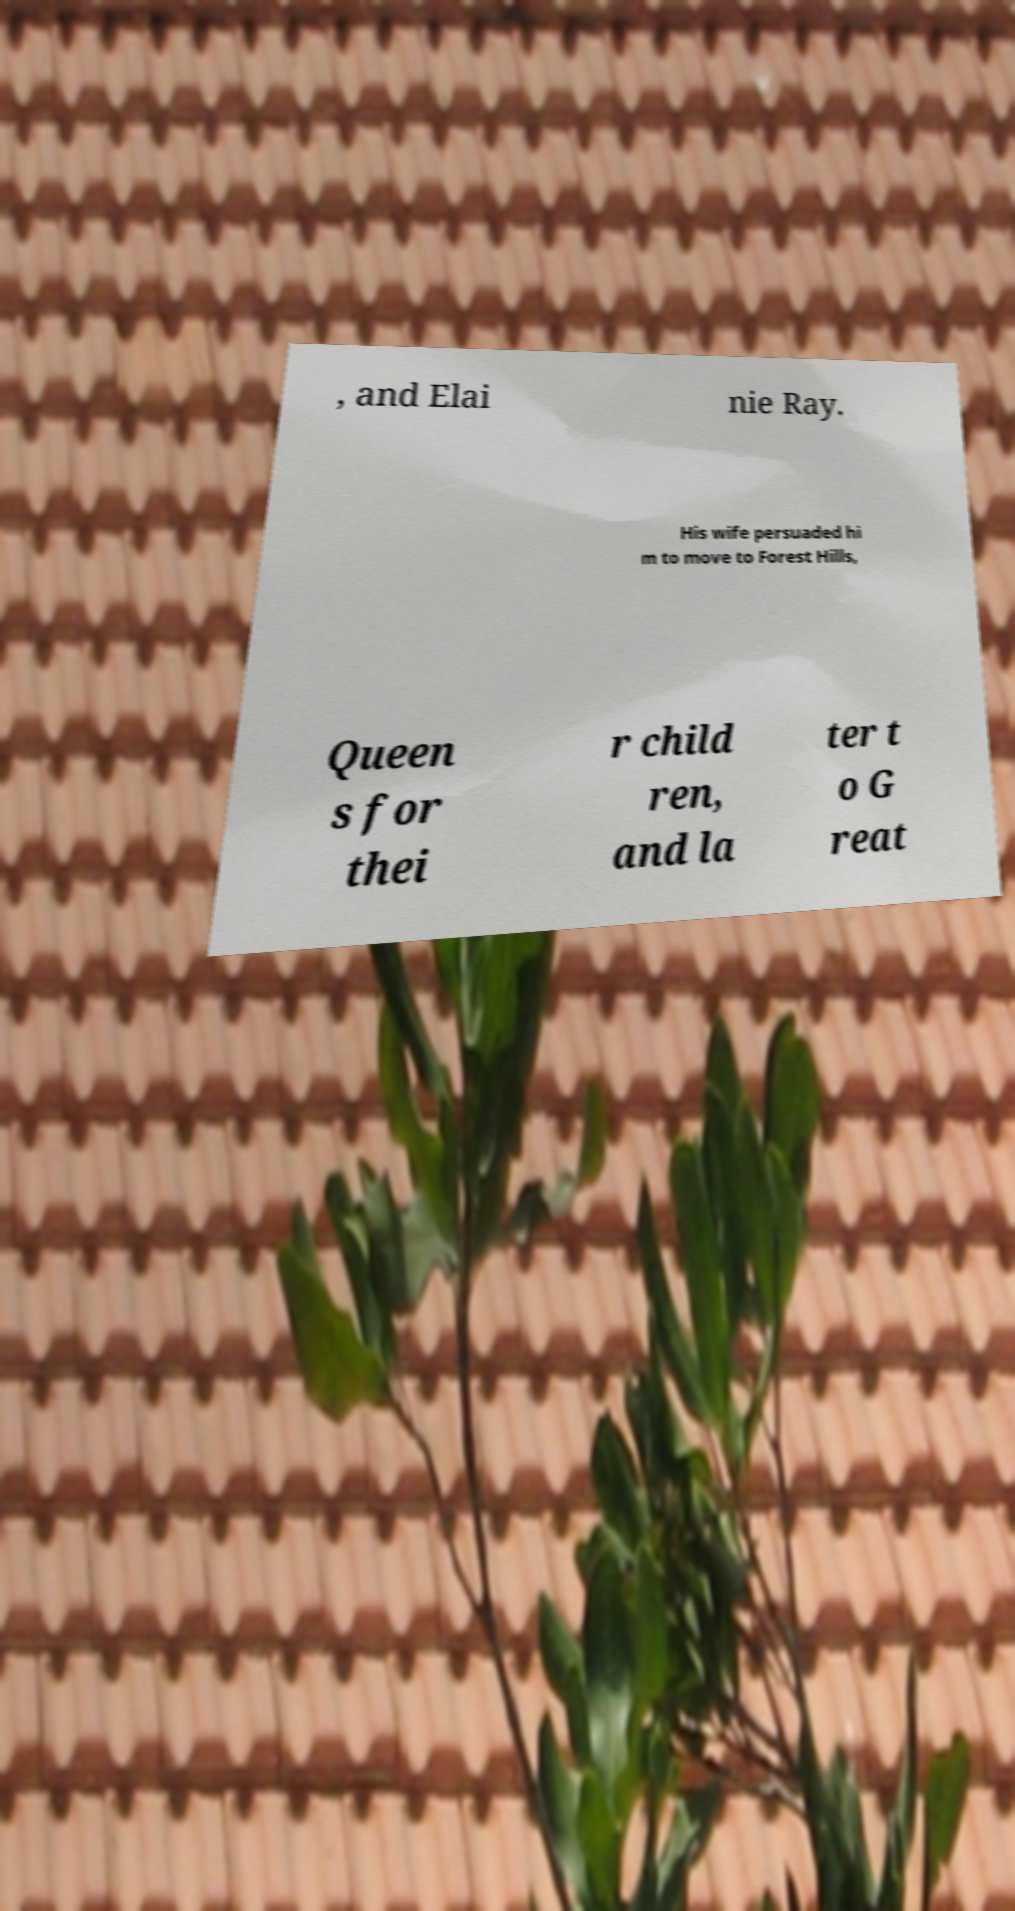I need the written content from this picture converted into text. Can you do that? , and Elai nie Ray. His wife persuaded hi m to move to Forest Hills, Queen s for thei r child ren, and la ter t o G reat 